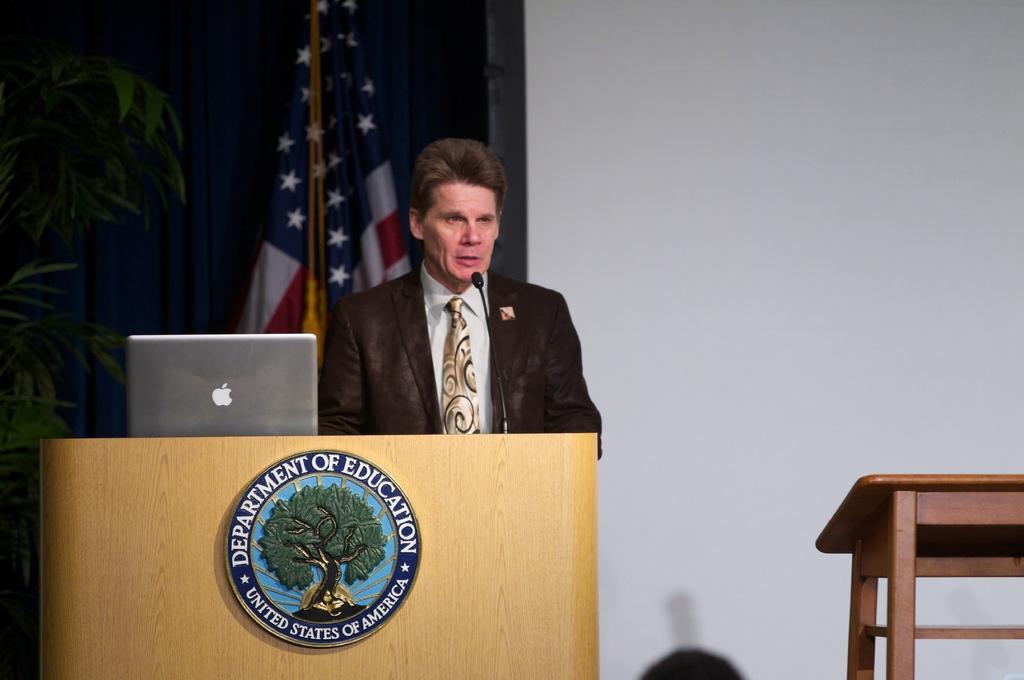Can you describe this image briefly? In the picture we can see a man wearing suit standing behind wooden podium on which there is microphone, laptop, on right side of the picture there is a table and in the background of the picture there is plant, flag and there is a wall. 